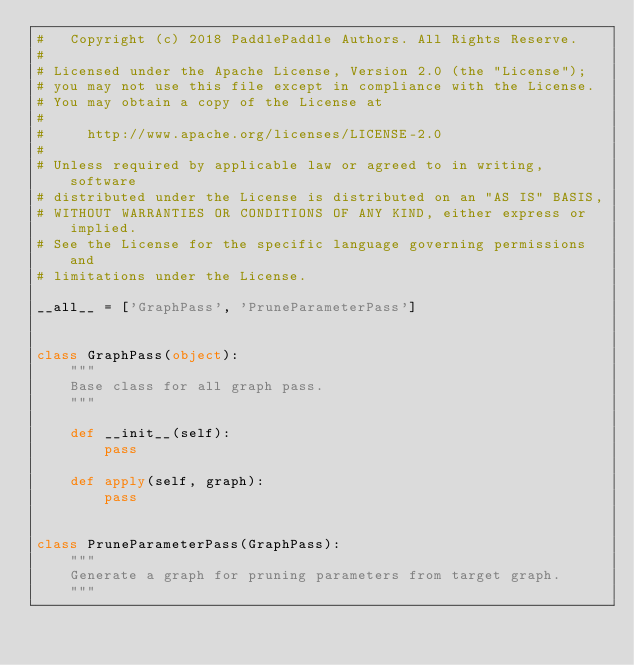<code> <loc_0><loc_0><loc_500><loc_500><_Python_>#   Copyright (c) 2018 PaddlePaddle Authors. All Rights Reserve.
#
# Licensed under the Apache License, Version 2.0 (the "License");
# you may not use this file except in compliance with the License.
# You may obtain a copy of the License at
#
#     http://www.apache.org/licenses/LICENSE-2.0
#
# Unless required by applicable law or agreed to in writing, software
# distributed under the License is distributed on an "AS IS" BASIS,
# WITHOUT WARRANTIES OR CONDITIONS OF ANY KIND, either express or implied.
# See the License for the specific language governing permissions and
# limitations under the License.

__all__ = ['GraphPass', 'PruneParameterPass']


class GraphPass(object):
    """
    Base class for all graph pass.
    """

    def __init__(self):
        pass

    def apply(self, graph):
        pass


class PruneParameterPass(GraphPass):
    """
    Generate a graph for pruning parameters from target graph.
    """
</code> 